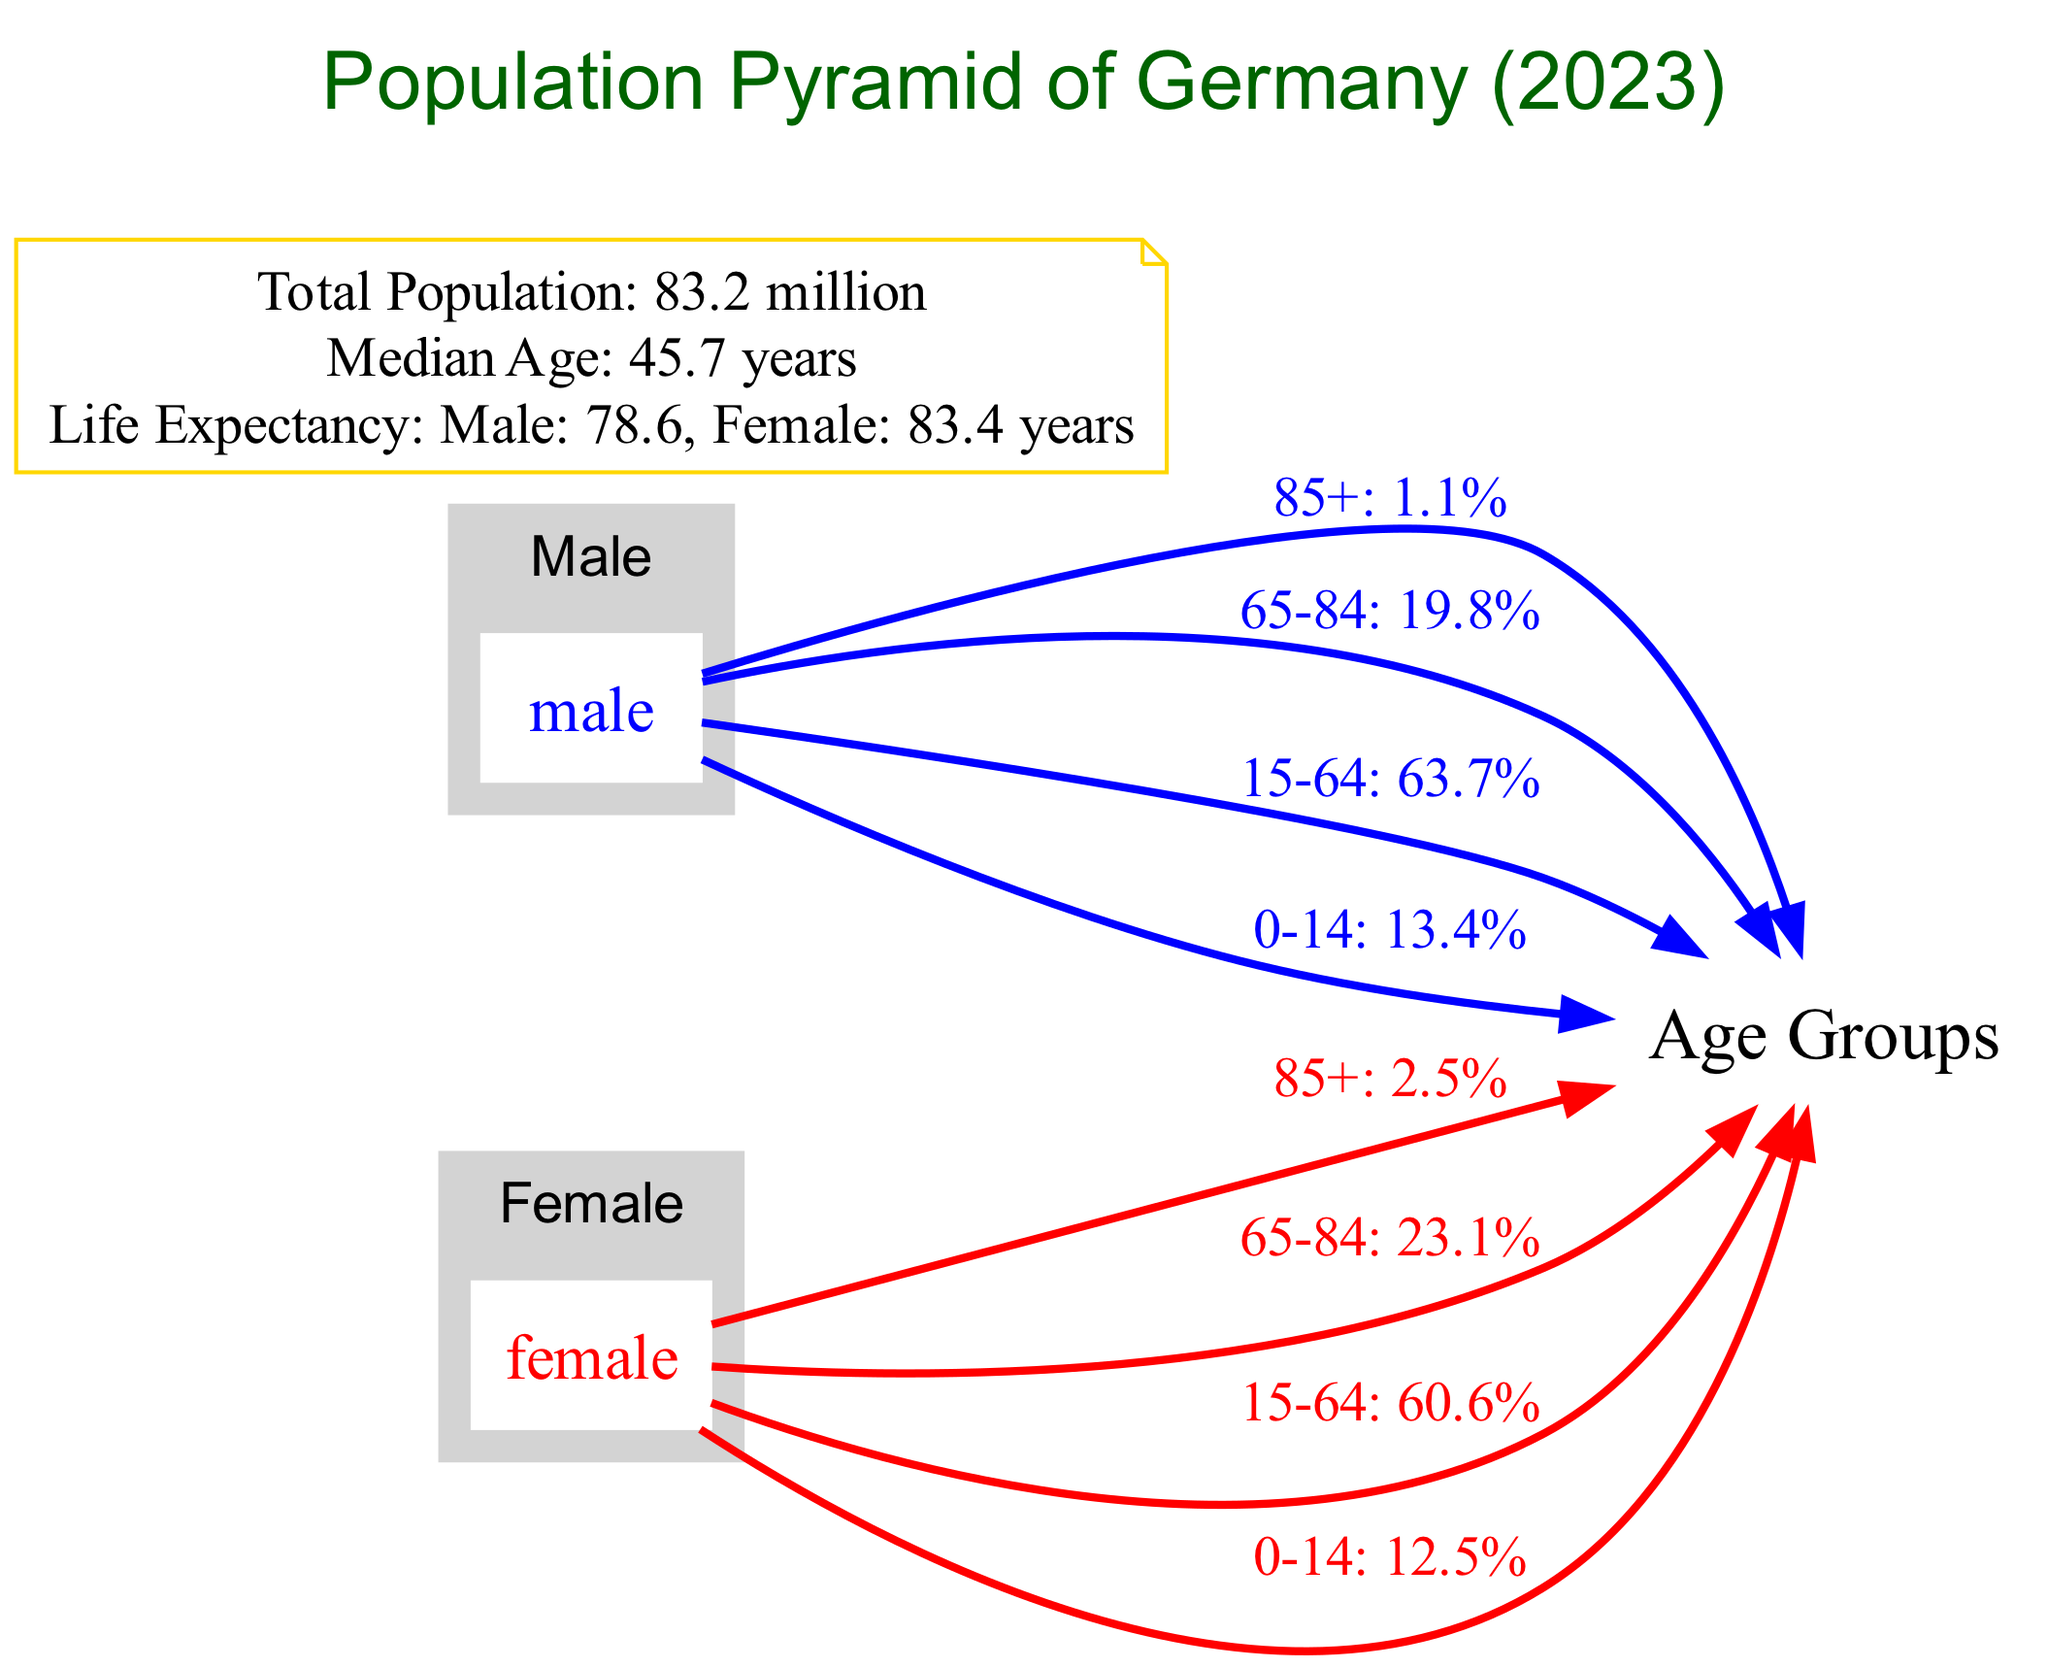What is the percentage of males aged 85 and over? The diagram indicates that the percentage of males in the 85+ age group is shown in the edge connected from the male node to the age_groups node, specifically labeled as "85+: 1.1%."
Answer: 1.1% What is the total population of Germany according to the diagram? The total population is mentioned in the attributes section of the diagram. It states, "Total Population: 83.2 million."
Answer: 83.2 million Which gender has a higher life expectancy according to the diagram? The diagram provides life expectancy values for both genders in the attributes section. It states "Male: 78.6 years" and "Female: 83.4 years," indicating that females have the higher life expectancy.
Answer: Female What is the percentage of females in the age group of 65 to 84? The percentage of females aged 65 to 84 is found in the edge connected from the female node to the age_groups node, specifically labeled as "65-84: 23.1%."
Answer: 23.1% How many age groups are represented in the diagram? The diagram categorizes age groups as 0-14, 15-64, 65-84, and 85+, which totals four distinct age groups.
Answer: 4 What does the median age figure indicate about the population structure? The median age is given as "Median Age: 45.7 years," which suggests that the population is aged, reflecting the distribution of age groups where a significant portion falls over 45 years.
Answer: 45.7 years Which gender has a larger percentage in the 15 to 64 age group? The percentage for males is "15-64: 63.7%" and for females is "15-64: 60.6%." Since 63.7% is greater than 60.6%, males have a larger percentage in this age group.
Answer: Male What is the label of the node that connects males and females to age groups? The connecting node for both genders to age groups is simply labeled as "Age Groups." This indicates the classification of individuals into different age bins.
Answer: Age Groups What is the life expectancy gap between genders as shown in the diagram? The life expectancy for males is 78.6 years and for females is 83.4 years. To find the gap, we subtract 78.6 from 83.4, which equals a gap of 4.8 years.
Answer: 4.8 years 